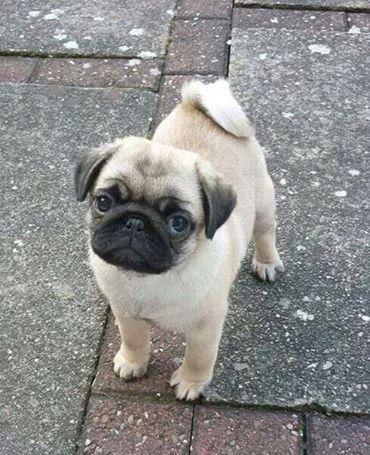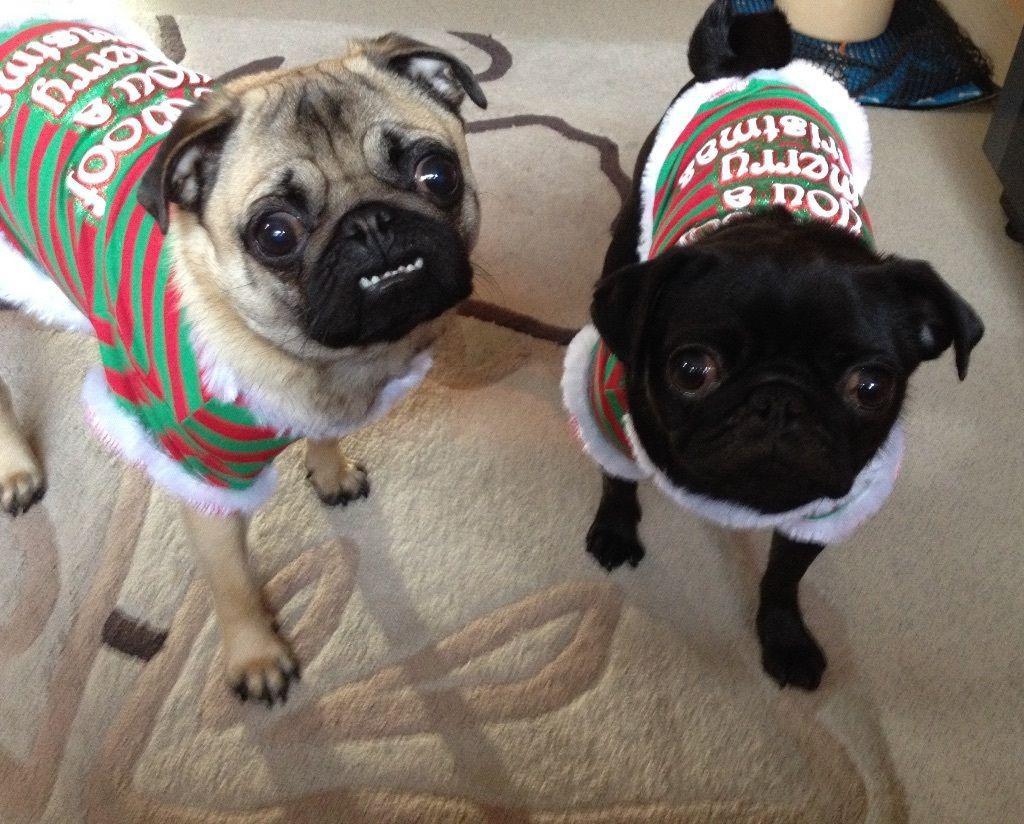The first image is the image on the left, the second image is the image on the right. Analyze the images presented: Is the assertion "An animal wearing clothing is present." valid? Answer yes or no. Yes. The first image is the image on the left, the second image is the image on the right. Analyze the images presented: Is the assertion "Four dogs are in sand." valid? Answer yes or no. No. 